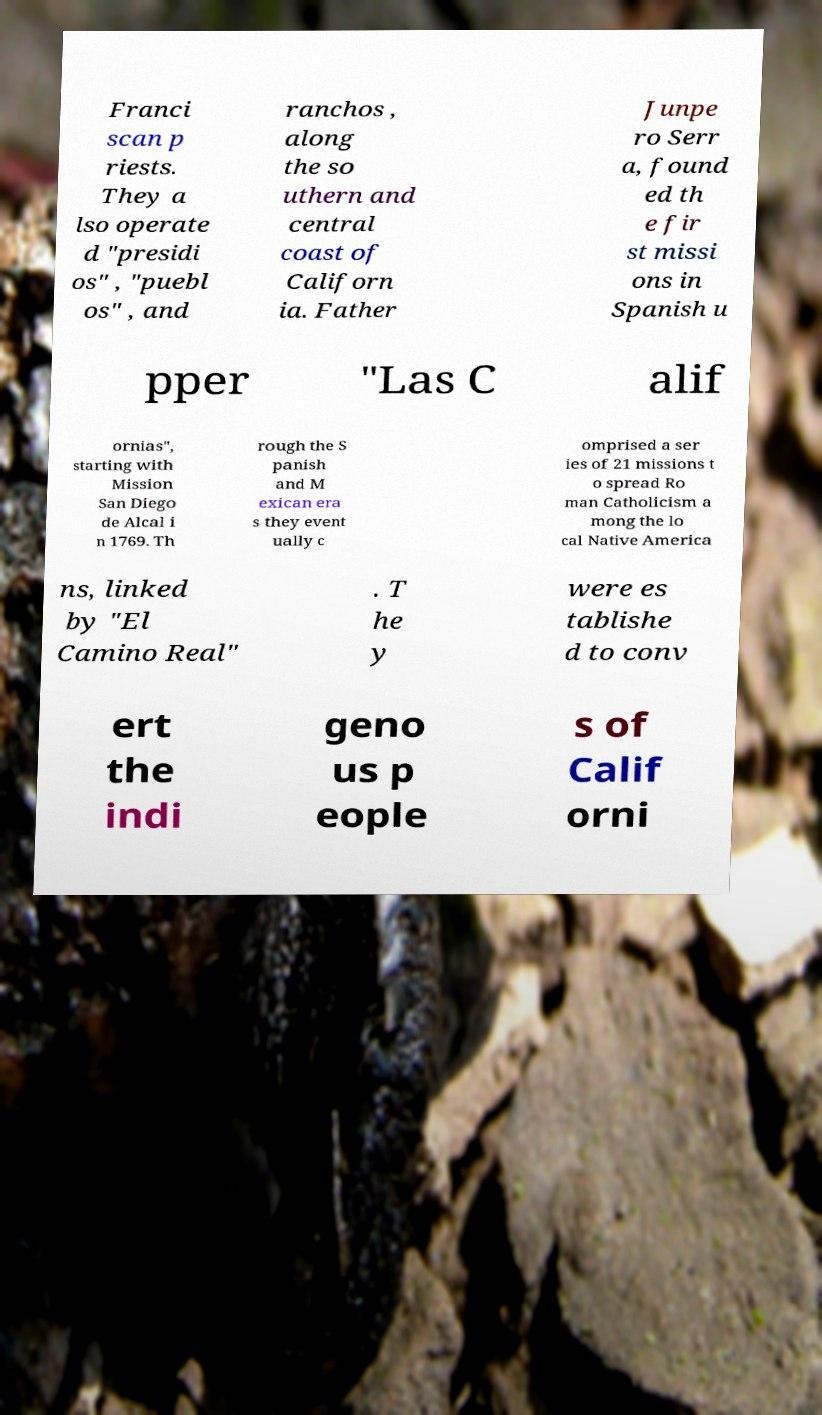Can you read and provide the text displayed in the image?This photo seems to have some interesting text. Can you extract and type it out for me? Franci scan p riests. They a lso operate d "presidi os" , "puebl os" , and ranchos , along the so uthern and central coast of Californ ia. Father Junpe ro Serr a, found ed th e fir st missi ons in Spanish u pper "Las C alif ornias", starting with Mission San Diego de Alcal i n 1769. Th rough the S panish and M exican era s they event ually c omprised a ser ies of 21 missions t o spread Ro man Catholicism a mong the lo cal Native America ns, linked by "El Camino Real" . T he y were es tablishe d to conv ert the indi geno us p eople s of Calif orni 